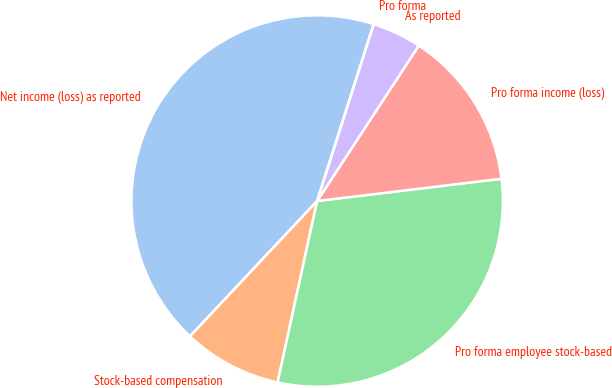Convert chart to OTSL. <chart><loc_0><loc_0><loc_500><loc_500><pie_chart><fcel>Net income (loss) as reported<fcel>Stock-based compensation<fcel>Pro forma employee stock-based<fcel>Pro forma income (loss)<fcel>As reported<fcel>Pro forma<nl><fcel>42.93%<fcel>8.59%<fcel>30.33%<fcel>13.87%<fcel>4.29%<fcel>0.0%<nl></chart> 